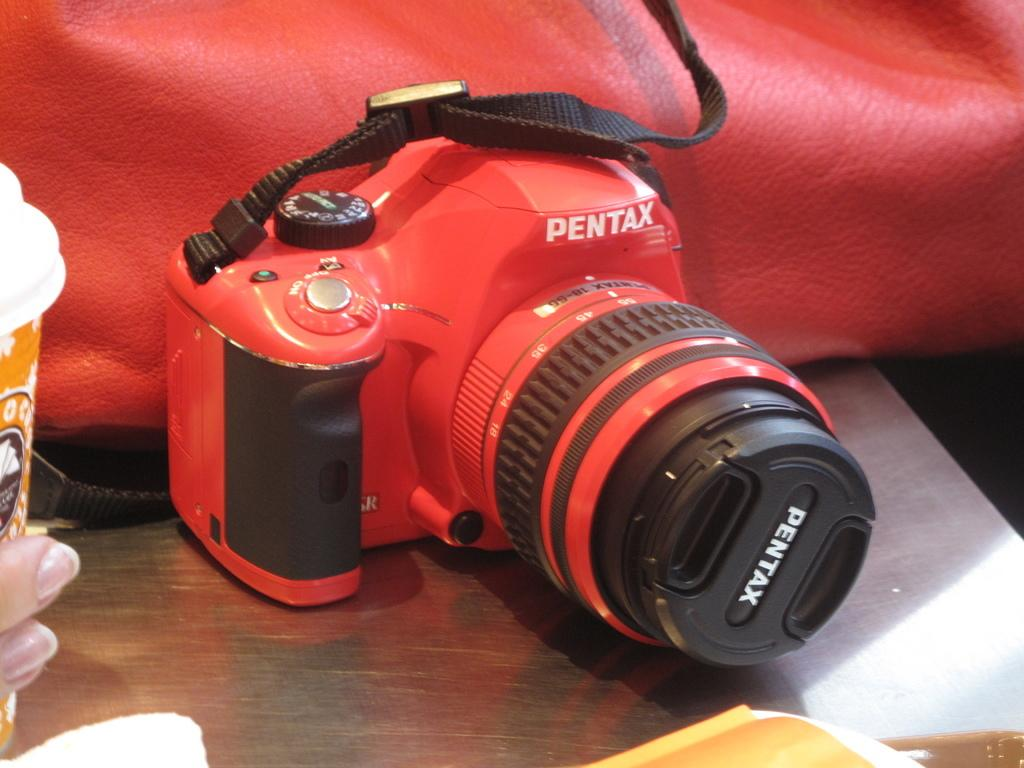What is the main subject of the image? The main subject of the image is a camera. What else can be seen in the image besides the camera? There is a bag in the image. Are there any other objects visible on the table in the image? Yes, there are other objects placed on the table in the image. How does the camera get its power in the image? The provided facts do not give us enough information to determine how the camera gets its power. What type of sun is visible in the image? There is no sun present in the image. 